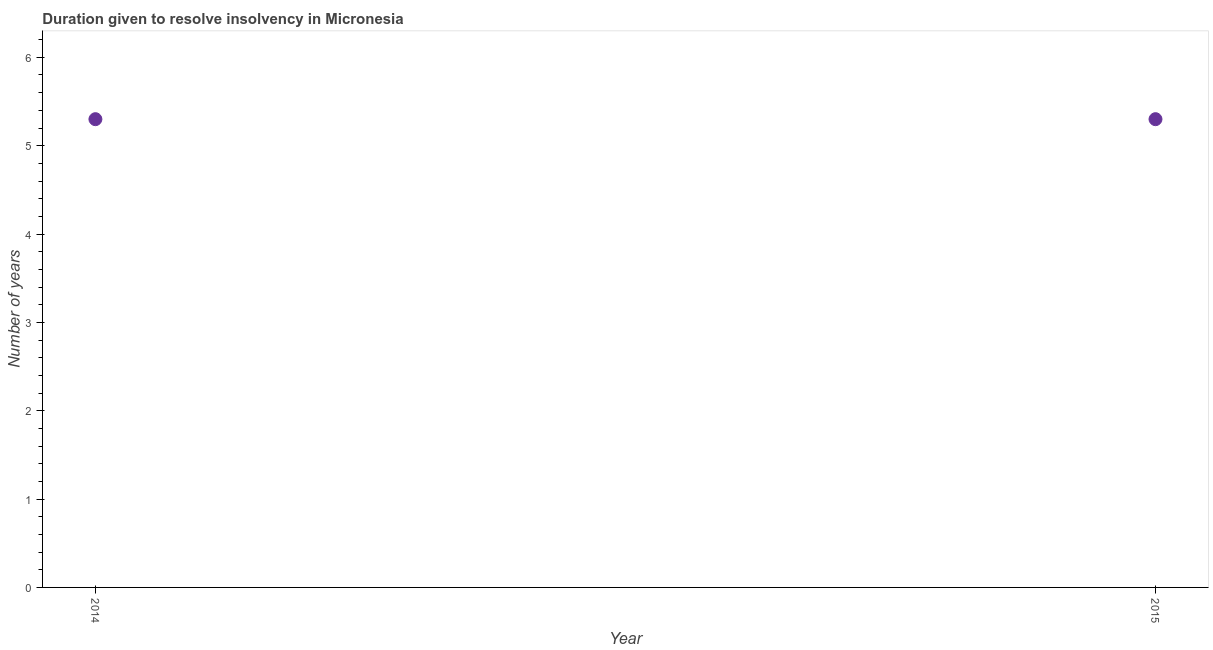Across all years, what is the maximum number of years to resolve insolvency?
Offer a terse response. 5.3. What is the average number of years to resolve insolvency per year?
Offer a terse response. 5.3. In how many years, is the number of years to resolve insolvency greater than 2.8 ?
Ensure brevity in your answer.  2. Do a majority of the years between 2015 and 2014 (inclusive) have number of years to resolve insolvency greater than 6 ?
Give a very brief answer. No. What is the ratio of the number of years to resolve insolvency in 2014 to that in 2015?
Keep it short and to the point. 1. In how many years, is the number of years to resolve insolvency greater than the average number of years to resolve insolvency taken over all years?
Your answer should be compact. 0. Does the number of years to resolve insolvency monotonically increase over the years?
Keep it short and to the point. No. How many years are there in the graph?
Offer a very short reply. 2. What is the title of the graph?
Give a very brief answer. Duration given to resolve insolvency in Micronesia. What is the label or title of the Y-axis?
Ensure brevity in your answer.  Number of years. 